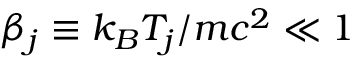Convert formula to latex. <formula><loc_0><loc_0><loc_500><loc_500>\beta _ { j } \equiv k _ { B } T _ { j } / m c ^ { 2 } \ll 1</formula> 